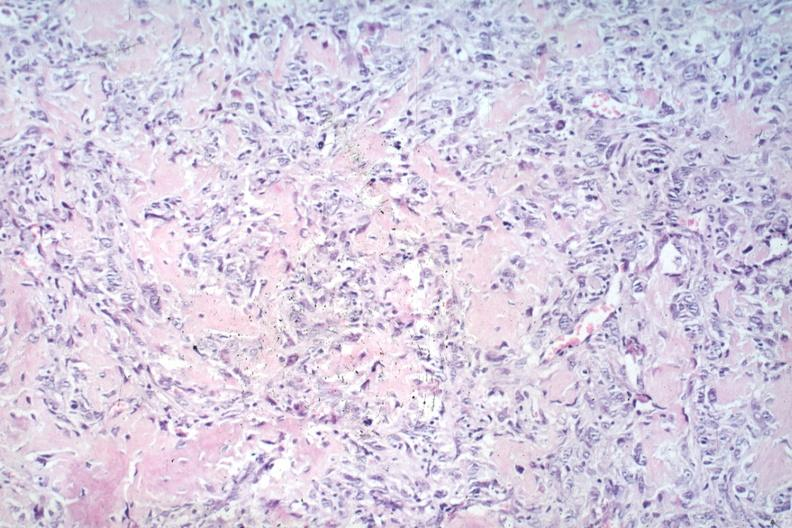does this image show anaplastic tumor cells and osteoid?
Answer the question using a single word or phrase. Yes 